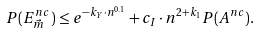<formula> <loc_0><loc_0><loc_500><loc_500>P ( E ^ { n c } _ { \vec { m } } ) \leq e ^ { - k _ { Y } \cdot n ^ { 0 . 1 } } + c _ { I } \cdot n ^ { 2 + k _ { 1 } } P ( A ^ { n c } ) .</formula> 